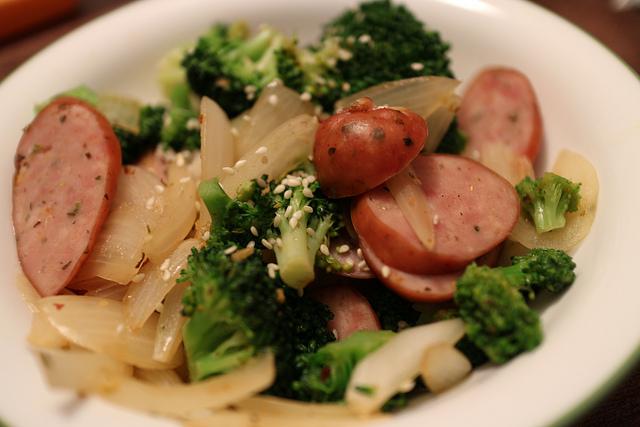What are the round sliced things?
Quick response, please. Sausage. Does this dish contain meat?
Be succinct. Yes. Is this pasta?
Give a very brief answer. No. What is the protein in this salad?
Quick response, please. Sausage. What meat is in this photo?
Short answer required. Sausage. Is this food in a bowl?
Write a very short answer. Yes. 